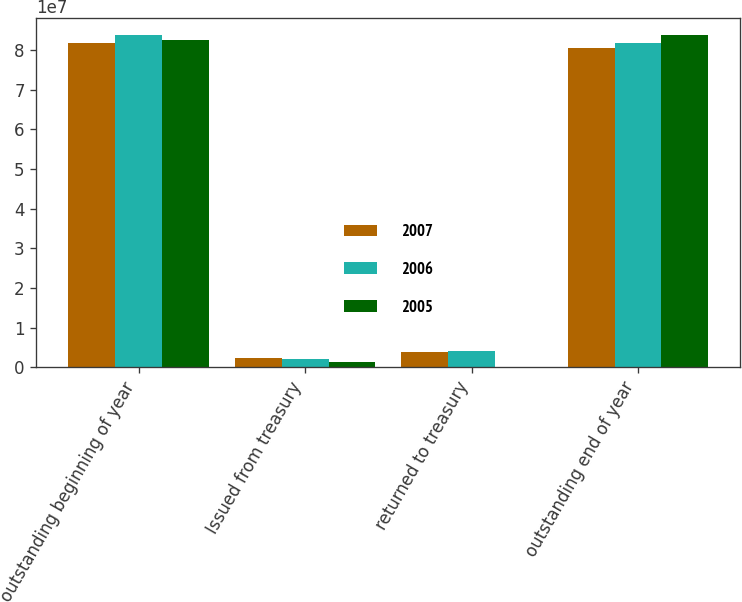<chart> <loc_0><loc_0><loc_500><loc_500><stacked_bar_chart><ecel><fcel>outstanding beginning of year<fcel>Issued from treasury<fcel>returned to treasury<fcel>outstanding end of year<nl><fcel>2007<fcel>8.18416e+07<fcel>2.32397e+06<fcel>3.78681e+06<fcel>8.03788e+07<nl><fcel>2006<fcel>8.37911e+07<fcel>2.07672e+06<fcel>4.02622e+06<fcel>8.18416e+07<nl><fcel>2005<fcel>8.24071e+07<fcel>1.38818e+06<fcel>4113<fcel>8.37911e+07<nl></chart> 